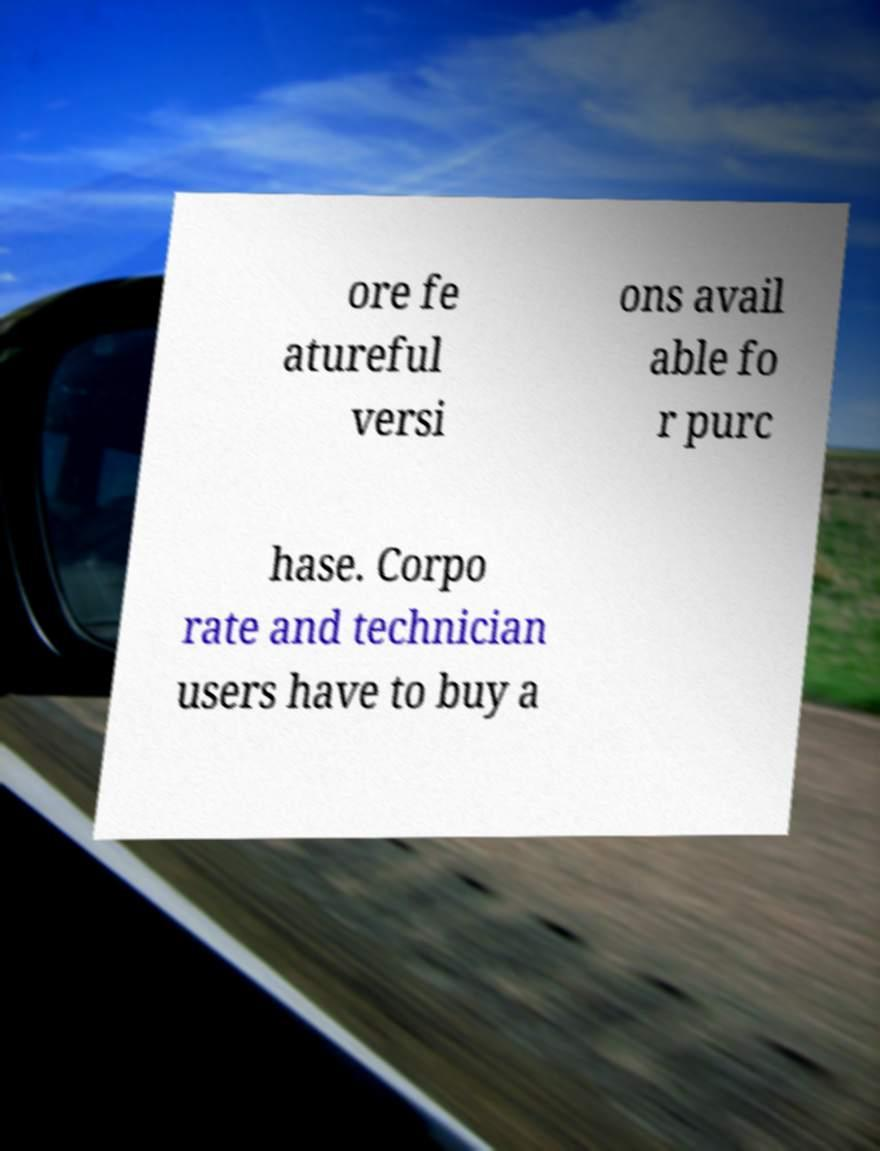Could you extract and type out the text from this image? ore fe atureful versi ons avail able fo r purc hase. Corpo rate and technician users have to buy a 